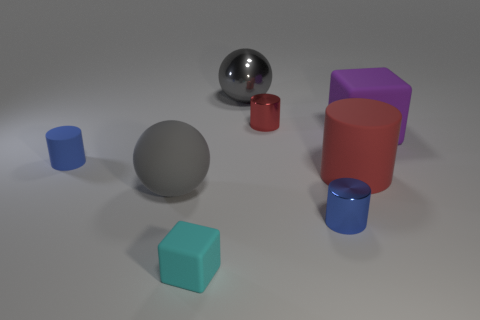Subtract all blue cylinders. How many were subtracted if there are1blue cylinders left? 1 Subtract all brown cylinders. Subtract all purple cubes. How many cylinders are left? 4 Add 1 big gray shiny things. How many objects exist? 9 Subtract all cubes. How many objects are left? 6 Add 6 shiny spheres. How many shiny spheres exist? 7 Subtract 0 yellow cylinders. How many objects are left? 8 Subtract all cyan shiny objects. Subtract all large cubes. How many objects are left? 7 Add 3 rubber spheres. How many rubber spheres are left? 4 